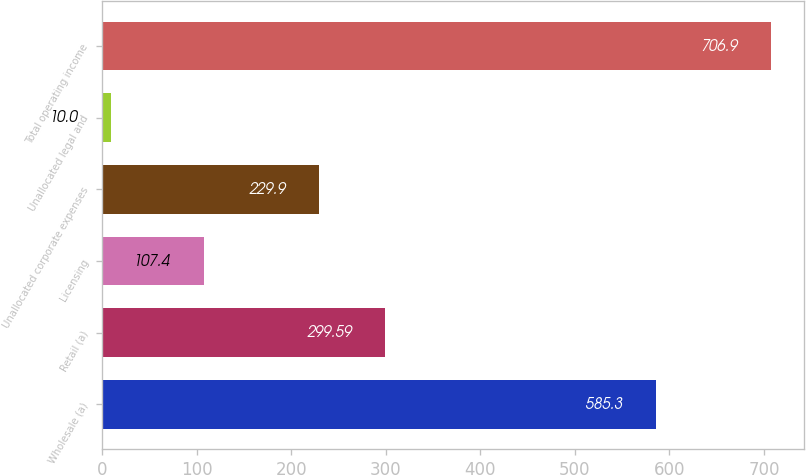<chart> <loc_0><loc_0><loc_500><loc_500><bar_chart><fcel>Wholesale (a)<fcel>Retail (a)<fcel>Licensing<fcel>Unallocated corporate expenses<fcel>Unallocated legal and<fcel>Total operating income<nl><fcel>585.3<fcel>299.59<fcel>107.4<fcel>229.9<fcel>10<fcel>706.9<nl></chart> 